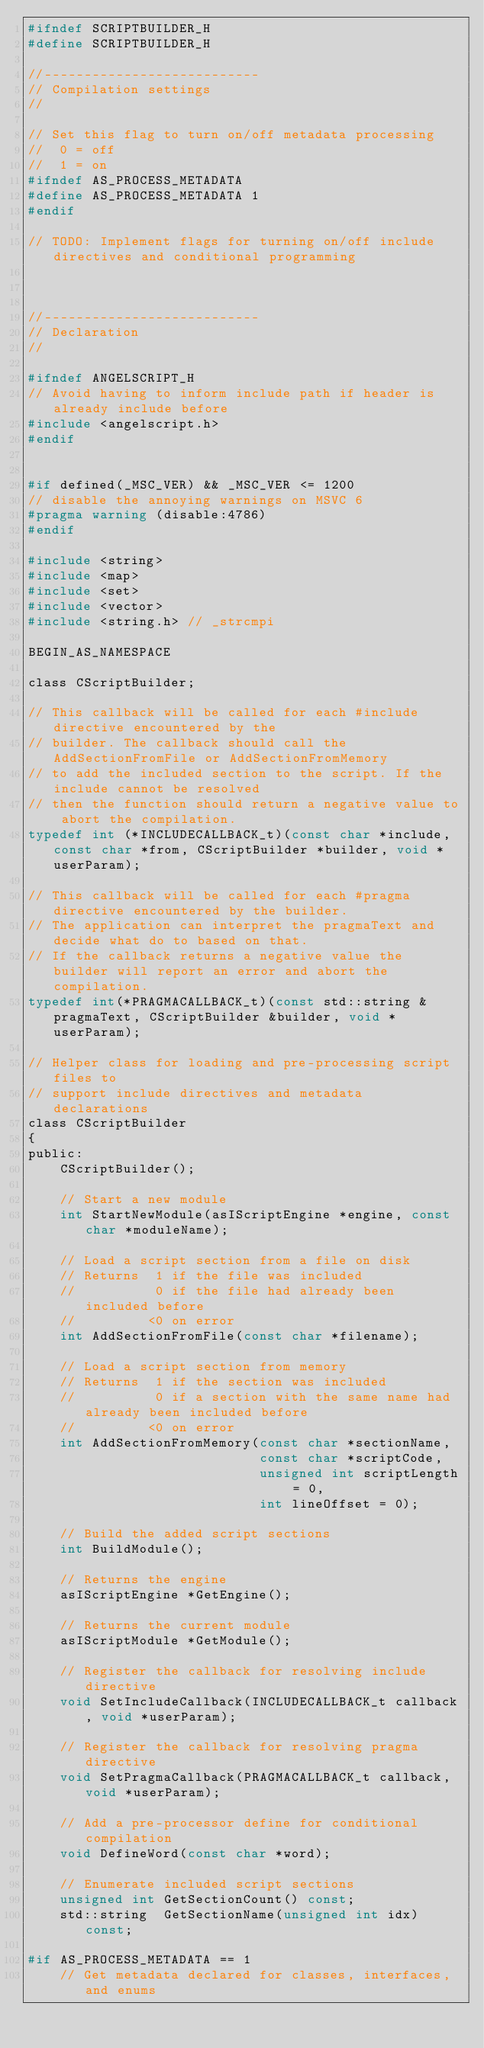Convert code to text. <code><loc_0><loc_0><loc_500><loc_500><_C_>#ifndef SCRIPTBUILDER_H
#define SCRIPTBUILDER_H

//---------------------------
// Compilation settings
//

// Set this flag to turn on/off metadata processing
//  0 = off
//  1 = on
#ifndef AS_PROCESS_METADATA
#define AS_PROCESS_METADATA 1
#endif

// TODO: Implement flags for turning on/off include directives and conditional programming



//---------------------------
// Declaration
//

#ifndef ANGELSCRIPT_H
// Avoid having to inform include path if header is already include before
#include <angelscript.h>
#endif


#if defined(_MSC_VER) && _MSC_VER <= 1200
// disable the annoying warnings on MSVC 6
#pragma warning (disable:4786)
#endif

#include <string>
#include <map>
#include <set>
#include <vector>
#include <string.h> // _strcmpi

BEGIN_AS_NAMESPACE

class CScriptBuilder;

// This callback will be called for each #include directive encountered by the
// builder. The callback should call the AddSectionFromFile or AddSectionFromMemory
// to add the included section to the script. If the include cannot be resolved
// then the function should return a negative value to abort the compilation.
typedef int (*INCLUDECALLBACK_t)(const char *include, const char *from, CScriptBuilder *builder, void *userParam);

// This callback will be called for each #pragma directive encountered by the builder.
// The application can interpret the pragmaText and decide what do to based on that.
// If the callback returns a negative value the builder will report an error and abort the compilation.
typedef int(*PRAGMACALLBACK_t)(const std::string &pragmaText, CScriptBuilder &builder, void *userParam);

// Helper class for loading and pre-processing script files to
// support include directives and metadata declarations
class CScriptBuilder
{
public:
	CScriptBuilder();

	// Start a new module
	int StartNewModule(asIScriptEngine *engine, const char *moduleName);

	// Load a script section from a file on disk
	// Returns  1 if the file was included
	//          0 if the file had already been included before
	//         <0 on error
	int AddSectionFromFile(const char *filename);

	// Load a script section from memory
	// Returns  1 if the section was included
	//          0 if a section with the same name had already been included before
	//         <0 on error
	int AddSectionFromMemory(const char *sectionName,
							 const char *scriptCode,
							 unsigned int scriptLength = 0,
							 int lineOffset = 0);

	// Build the added script sections
	int BuildModule();

	// Returns the engine
	asIScriptEngine *GetEngine();

	// Returns the current module
	asIScriptModule *GetModule();

	// Register the callback for resolving include directive
	void SetIncludeCallback(INCLUDECALLBACK_t callback, void *userParam);

	// Register the callback for resolving pragma directive
	void SetPragmaCallback(PRAGMACALLBACK_t callback, void *userParam);

	// Add a pre-processor define for conditional compilation
	void DefineWord(const char *word);

	// Enumerate included script sections
	unsigned int GetSectionCount() const;
	std::string  GetSectionName(unsigned int idx) const;

#if AS_PROCESS_METADATA == 1
	// Get metadata declared for classes, interfaces, and enums</code> 